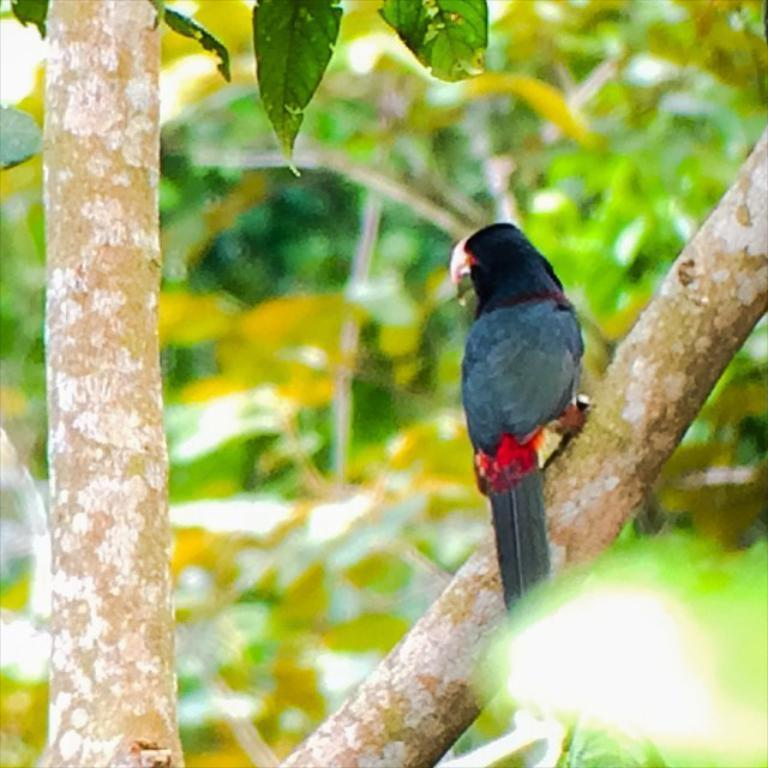What type of animal can be seen in the image? There is a bird in the image. Where is the bird located? The bird is on a tree branch. What can be seen in the background of the image? There are leaves visible in the background of the image. What type of pancake is the bird eating in the image? There is no pancake present in the image; it features a bird on a tree branch. What hobbies does the bird have, as depicted in the image? The image does not provide information about the bird's hobbies; it only shows the bird on a tree branch. 